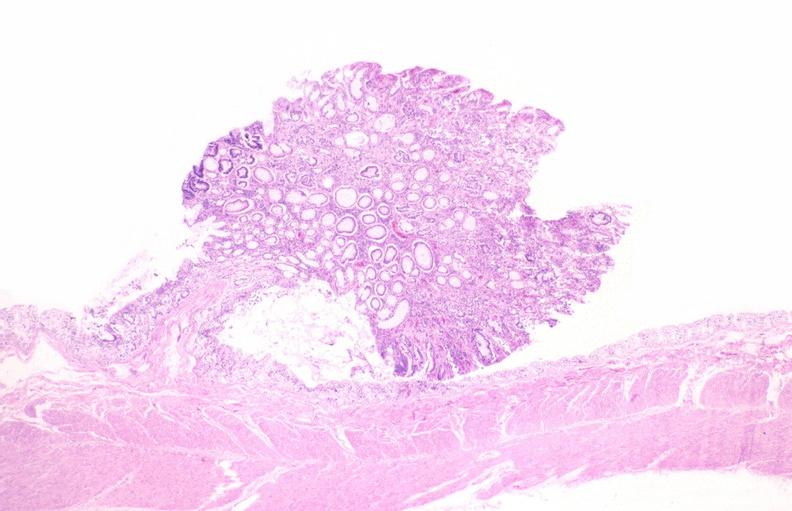s gastrointestinal present?
Answer the question using a single word or phrase. Yes 